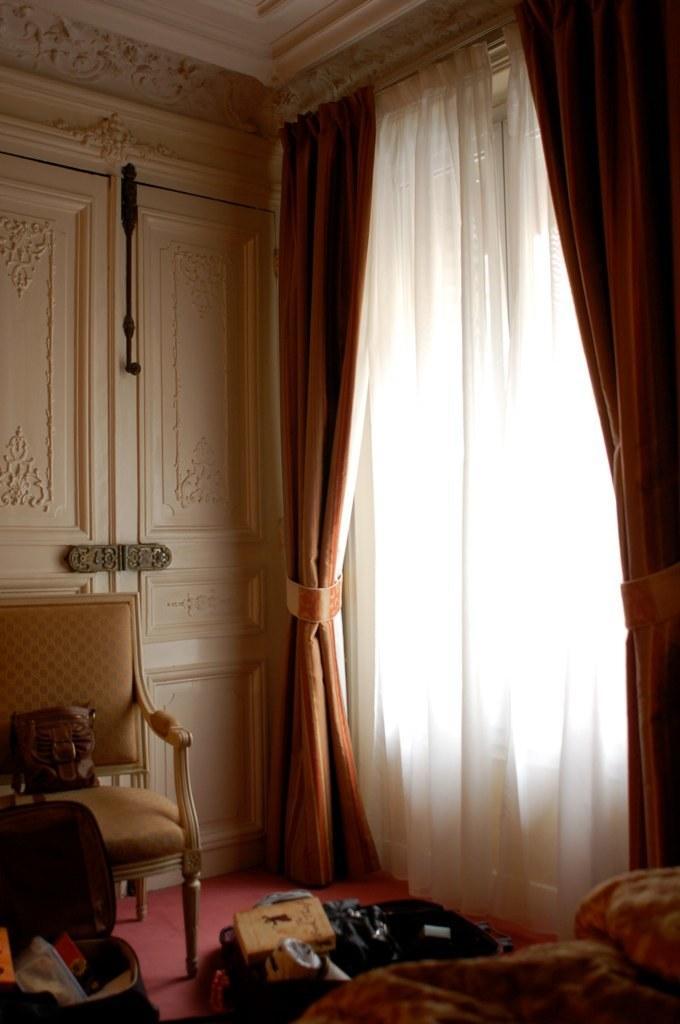Can you describe this image briefly? In this picture I can see a chair and curtains and I can see a bag on the floor and I can see a handbag on the chair and a door in the back, looks like a bed and a pillow on the right side of the picture. 